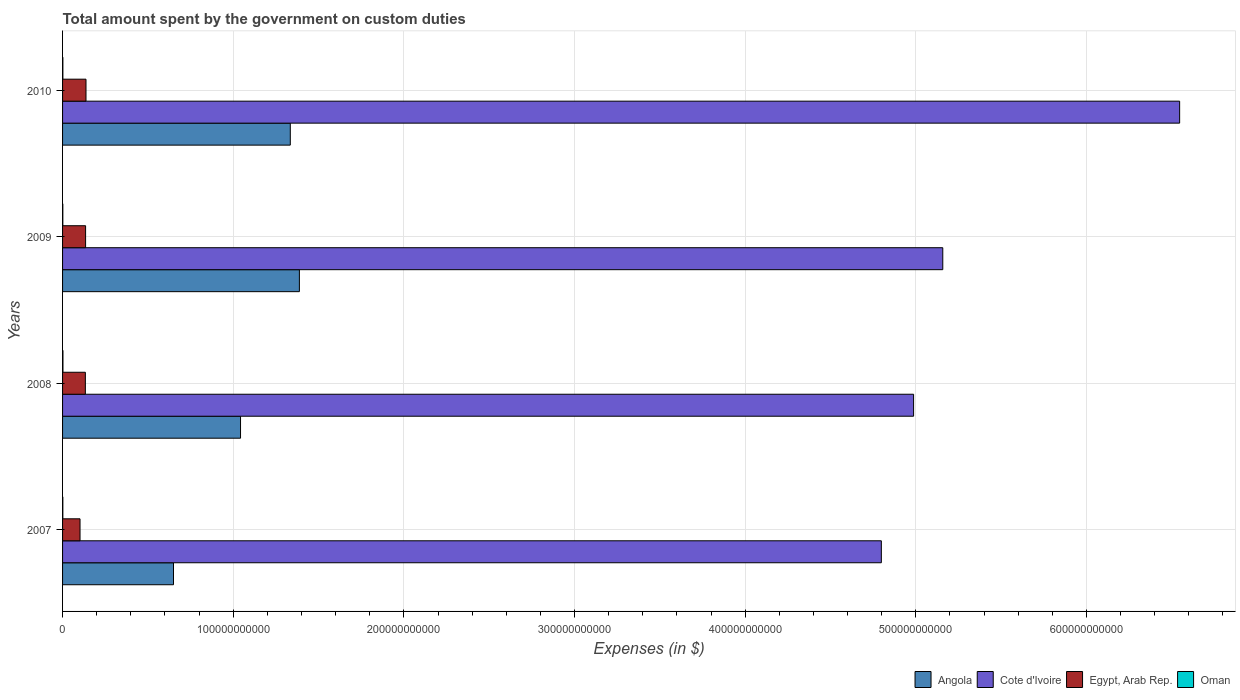Are the number of bars on each tick of the Y-axis equal?
Ensure brevity in your answer.  Yes. What is the label of the 3rd group of bars from the top?
Offer a terse response. 2008. In how many cases, is the number of bars for a given year not equal to the number of legend labels?
Your answer should be very brief. 0. What is the amount spent on custom duties by the government in Oman in 2010?
Offer a terse response. 1.80e+08. Across all years, what is the maximum amount spent on custom duties by the government in Oman?
Your answer should be compact. 2.27e+08. Across all years, what is the minimum amount spent on custom duties by the government in Egypt, Arab Rep.?
Your answer should be very brief. 1.02e+1. In which year was the amount spent on custom duties by the government in Egypt, Arab Rep. minimum?
Your answer should be compact. 2007. What is the total amount spent on custom duties by the government in Oman in the graph?
Your response must be concise. 7.24e+08. What is the difference between the amount spent on custom duties by the government in Egypt, Arab Rep. in 2008 and that in 2009?
Your answer should be very brief. -1.35e+08. What is the difference between the amount spent on custom duties by the government in Angola in 2010 and the amount spent on custom duties by the government in Oman in 2009?
Give a very brief answer. 1.33e+11. What is the average amount spent on custom duties by the government in Angola per year?
Offer a terse response. 1.10e+11. In the year 2007, what is the difference between the amount spent on custom duties by the government in Egypt, Arab Rep. and amount spent on custom duties by the government in Angola?
Offer a very short reply. -5.48e+1. What is the ratio of the amount spent on custom duties by the government in Cote d'Ivoire in 2008 to that in 2009?
Ensure brevity in your answer.  0.97. Is the amount spent on custom duties by the government in Cote d'Ivoire in 2008 less than that in 2009?
Make the answer very short. Yes. What is the difference between the highest and the second highest amount spent on custom duties by the government in Cote d'Ivoire?
Make the answer very short. 1.39e+11. What is the difference between the highest and the lowest amount spent on custom duties by the government in Egypt, Arab Rep.?
Provide a succinct answer. 3.50e+09. Is the sum of the amount spent on custom duties by the government in Egypt, Arab Rep. in 2008 and 2010 greater than the maximum amount spent on custom duties by the government in Oman across all years?
Give a very brief answer. Yes. What does the 1st bar from the top in 2008 represents?
Your response must be concise. Oman. What does the 1st bar from the bottom in 2010 represents?
Give a very brief answer. Angola. How many bars are there?
Keep it short and to the point. 16. Are all the bars in the graph horizontal?
Make the answer very short. Yes. What is the difference between two consecutive major ticks on the X-axis?
Keep it short and to the point. 1.00e+11. Are the values on the major ticks of X-axis written in scientific E-notation?
Ensure brevity in your answer.  No. Does the graph contain any zero values?
Provide a succinct answer. No. Does the graph contain grids?
Ensure brevity in your answer.  Yes. How many legend labels are there?
Your answer should be compact. 4. What is the title of the graph?
Your answer should be very brief. Total amount spent by the government on custom duties. What is the label or title of the X-axis?
Provide a short and direct response. Expenses (in $). What is the label or title of the Y-axis?
Offer a terse response. Years. What is the Expenses (in $) in Angola in 2007?
Provide a succinct answer. 6.50e+1. What is the Expenses (in $) in Cote d'Ivoire in 2007?
Your response must be concise. 4.80e+11. What is the Expenses (in $) of Egypt, Arab Rep. in 2007?
Offer a terse response. 1.02e+1. What is the Expenses (in $) of Oman in 2007?
Give a very brief answer. 1.60e+08. What is the Expenses (in $) in Angola in 2008?
Provide a short and direct response. 1.04e+11. What is the Expenses (in $) in Cote d'Ivoire in 2008?
Your answer should be compact. 4.99e+11. What is the Expenses (in $) of Egypt, Arab Rep. in 2008?
Your answer should be very brief. 1.34e+1. What is the Expenses (in $) of Oman in 2008?
Keep it short and to the point. 2.27e+08. What is the Expenses (in $) of Angola in 2009?
Provide a short and direct response. 1.39e+11. What is the Expenses (in $) of Cote d'Ivoire in 2009?
Provide a short and direct response. 5.16e+11. What is the Expenses (in $) of Egypt, Arab Rep. in 2009?
Your answer should be very brief. 1.35e+1. What is the Expenses (in $) of Oman in 2009?
Give a very brief answer. 1.58e+08. What is the Expenses (in $) in Angola in 2010?
Your response must be concise. 1.33e+11. What is the Expenses (in $) in Cote d'Ivoire in 2010?
Offer a very short reply. 6.55e+11. What is the Expenses (in $) of Egypt, Arab Rep. in 2010?
Your answer should be compact. 1.37e+1. What is the Expenses (in $) in Oman in 2010?
Give a very brief answer. 1.80e+08. Across all years, what is the maximum Expenses (in $) in Angola?
Your response must be concise. 1.39e+11. Across all years, what is the maximum Expenses (in $) of Cote d'Ivoire?
Your answer should be very brief. 6.55e+11. Across all years, what is the maximum Expenses (in $) of Egypt, Arab Rep.?
Make the answer very short. 1.37e+1. Across all years, what is the maximum Expenses (in $) in Oman?
Your response must be concise. 2.27e+08. Across all years, what is the minimum Expenses (in $) of Angola?
Your response must be concise. 6.50e+1. Across all years, what is the minimum Expenses (in $) of Cote d'Ivoire?
Offer a very short reply. 4.80e+11. Across all years, what is the minimum Expenses (in $) of Egypt, Arab Rep.?
Give a very brief answer. 1.02e+1. Across all years, what is the minimum Expenses (in $) of Oman?
Provide a short and direct response. 1.58e+08. What is the total Expenses (in $) in Angola in the graph?
Ensure brevity in your answer.  4.42e+11. What is the total Expenses (in $) in Cote d'Ivoire in the graph?
Keep it short and to the point. 2.15e+12. What is the total Expenses (in $) in Egypt, Arab Rep. in the graph?
Make the answer very short. 5.08e+1. What is the total Expenses (in $) in Oman in the graph?
Provide a succinct answer. 7.24e+08. What is the difference between the Expenses (in $) in Angola in 2007 and that in 2008?
Make the answer very short. -3.93e+1. What is the difference between the Expenses (in $) in Cote d'Ivoire in 2007 and that in 2008?
Your answer should be very brief. -1.89e+1. What is the difference between the Expenses (in $) of Egypt, Arab Rep. in 2007 and that in 2008?
Offer a very short reply. -3.13e+09. What is the difference between the Expenses (in $) of Oman in 2007 and that in 2008?
Your answer should be very brief. -6.70e+07. What is the difference between the Expenses (in $) of Angola in 2007 and that in 2009?
Provide a succinct answer. -7.38e+1. What is the difference between the Expenses (in $) in Cote d'Ivoire in 2007 and that in 2009?
Your answer should be very brief. -3.60e+1. What is the difference between the Expenses (in $) of Egypt, Arab Rep. in 2007 and that in 2009?
Your response must be concise. -3.26e+09. What is the difference between the Expenses (in $) of Oman in 2007 and that in 2009?
Offer a terse response. 1.50e+06. What is the difference between the Expenses (in $) of Angola in 2007 and that in 2010?
Your answer should be very brief. -6.84e+1. What is the difference between the Expenses (in $) of Cote d'Ivoire in 2007 and that in 2010?
Provide a succinct answer. -1.75e+11. What is the difference between the Expenses (in $) in Egypt, Arab Rep. in 2007 and that in 2010?
Ensure brevity in your answer.  -3.50e+09. What is the difference between the Expenses (in $) in Oman in 2007 and that in 2010?
Your response must be concise. -2.00e+07. What is the difference between the Expenses (in $) in Angola in 2008 and that in 2009?
Your answer should be very brief. -3.45e+1. What is the difference between the Expenses (in $) in Cote d'Ivoire in 2008 and that in 2009?
Offer a very short reply. -1.71e+1. What is the difference between the Expenses (in $) of Egypt, Arab Rep. in 2008 and that in 2009?
Offer a very short reply. -1.35e+08. What is the difference between the Expenses (in $) in Oman in 2008 and that in 2009?
Keep it short and to the point. 6.85e+07. What is the difference between the Expenses (in $) in Angola in 2008 and that in 2010?
Keep it short and to the point. -2.92e+1. What is the difference between the Expenses (in $) of Cote d'Ivoire in 2008 and that in 2010?
Provide a short and direct response. -1.56e+11. What is the difference between the Expenses (in $) of Egypt, Arab Rep. in 2008 and that in 2010?
Provide a succinct answer. -3.72e+08. What is the difference between the Expenses (in $) of Oman in 2008 and that in 2010?
Your answer should be very brief. 4.70e+07. What is the difference between the Expenses (in $) in Angola in 2009 and that in 2010?
Provide a succinct answer. 5.33e+09. What is the difference between the Expenses (in $) of Cote d'Ivoire in 2009 and that in 2010?
Give a very brief answer. -1.39e+11. What is the difference between the Expenses (in $) of Egypt, Arab Rep. in 2009 and that in 2010?
Your answer should be compact. -2.37e+08. What is the difference between the Expenses (in $) of Oman in 2009 and that in 2010?
Provide a short and direct response. -2.15e+07. What is the difference between the Expenses (in $) of Angola in 2007 and the Expenses (in $) of Cote d'Ivoire in 2008?
Offer a terse response. -4.34e+11. What is the difference between the Expenses (in $) in Angola in 2007 and the Expenses (in $) in Egypt, Arab Rep. in 2008?
Provide a succinct answer. 5.16e+1. What is the difference between the Expenses (in $) in Angola in 2007 and the Expenses (in $) in Oman in 2008?
Provide a succinct answer. 6.48e+1. What is the difference between the Expenses (in $) in Cote d'Ivoire in 2007 and the Expenses (in $) in Egypt, Arab Rep. in 2008?
Give a very brief answer. 4.66e+11. What is the difference between the Expenses (in $) in Cote d'Ivoire in 2007 and the Expenses (in $) in Oman in 2008?
Offer a terse response. 4.80e+11. What is the difference between the Expenses (in $) in Egypt, Arab Rep. in 2007 and the Expenses (in $) in Oman in 2008?
Ensure brevity in your answer.  1.00e+1. What is the difference between the Expenses (in $) in Angola in 2007 and the Expenses (in $) in Cote d'Ivoire in 2009?
Make the answer very short. -4.51e+11. What is the difference between the Expenses (in $) of Angola in 2007 and the Expenses (in $) of Egypt, Arab Rep. in 2009?
Keep it short and to the point. 5.15e+1. What is the difference between the Expenses (in $) in Angola in 2007 and the Expenses (in $) in Oman in 2009?
Ensure brevity in your answer.  6.48e+1. What is the difference between the Expenses (in $) of Cote d'Ivoire in 2007 and the Expenses (in $) of Egypt, Arab Rep. in 2009?
Give a very brief answer. 4.66e+11. What is the difference between the Expenses (in $) in Cote d'Ivoire in 2007 and the Expenses (in $) in Oman in 2009?
Ensure brevity in your answer.  4.80e+11. What is the difference between the Expenses (in $) of Egypt, Arab Rep. in 2007 and the Expenses (in $) of Oman in 2009?
Offer a terse response. 1.01e+1. What is the difference between the Expenses (in $) in Angola in 2007 and the Expenses (in $) in Cote d'Ivoire in 2010?
Your response must be concise. -5.90e+11. What is the difference between the Expenses (in $) in Angola in 2007 and the Expenses (in $) in Egypt, Arab Rep. in 2010?
Ensure brevity in your answer.  5.13e+1. What is the difference between the Expenses (in $) in Angola in 2007 and the Expenses (in $) in Oman in 2010?
Your response must be concise. 6.48e+1. What is the difference between the Expenses (in $) of Cote d'Ivoire in 2007 and the Expenses (in $) of Egypt, Arab Rep. in 2010?
Your response must be concise. 4.66e+11. What is the difference between the Expenses (in $) of Cote d'Ivoire in 2007 and the Expenses (in $) of Oman in 2010?
Make the answer very short. 4.80e+11. What is the difference between the Expenses (in $) in Egypt, Arab Rep. in 2007 and the Expenses (in $) in Oman in 2010?
Your answer should be very brief. 1.01e+1. What is the difference between the Expenses (in $) in Angola in 2008 and the Expenses (in $) in Cote d'Ivoire in 2009?
Your response must be concise. -4.12e+11. What is the difference between the Expenses (in $) of Angola in 2008 and the Expenses (in $) of Egypt, Arab Rep. in 2009?
Make the answer very short. 9.08e+1. What is the difference between the Expenses (in $) of Angola in 2008 and the Expenses (in $) of Oman in 2009?
Keep it short and to the point. 1.04e+11. What is the difference between the Expenses (in $) of Cote d'Ivoire in 2008 and the Expenses (in $) of Egypt, Arab Rep. in 2009?
Keep it short and to the point. 4.85e+11. What is the difference between the Expenses (in $) in Cote d'Ivoire in 2008 and the Expenses (in $) in Oman in 2009?
Ensure brevity in your answer.  4.99e+11. What is the difference between the Expenses (in $) of Egypt, Arab Rep. in 2008 and the Expenses (in $) of Oman in 2009?
Provide a succinct answer. 1.32e+1. What is the difference between the Expenses (in $) in Angola in 2008 and the Expenses (in $) in Cote d'Ivoire in 2010?
Provide a short and direct response. -5.50e+11. What is the difference between the Expenses (in $) in Angola in 2008 and the Expenses (in $) in Egypt, Arab Rep. in 2010?
Make the answer very short. 9.06e+1. What is the difference between the Expenses (in $) in Angola in 2008 and the Expenses (in $) in Oman in 2010?
Your response must be concise. 1.04e+11. What is the difference between the Expenses (in $) of Cote d'Ivoire in 2008 and the Expenses (in $) of Egypt, Arab Rep. in 2010?
Provide a succinct answer. 4.85e+11. What is the difference between the Expenses (in $) of Cote d'Ivoire in 2008 and the Expenses (in $) of Oman in 2010?
Offer a very short reply. 4.99e+11. What is the difference between the Expenses (in $) in Egypt, Arab Rep. in 2008 and the Expenses (in $) in Oman in 2010?
Offer a terse response. 1.32e+1. What is the difference between the Expenses (in $) of Angola in 2009 and the Expenses (in $) of Cote d'Ivoire in 2010?
Your answer should be compact. -5.16e+11. What is the difference between the Expenses (in $) of Angola in 2009 and the Expenses (in $) of Egypt, Arab Rep. in 2010?
Keep it short and to the point. 1.25e+11. What is the difference between the Expenses (in $) of Angola in 2009 and the Expenses (in $) of Oman in 2010?
Your answer should be compact. 1.39e+11. What is the difference between the Expenses (in $) of Cote d'Ivoire in 2009 and the Expenses (in $) of Egypt, Arab Rep. in 2010?
Make the answer very short. 5.02e+11. What is the difference between the Expenses (in $) of Cote d'Ivoire in 2009 and the Expenses (in $) of Oman in 2010?
Provide a succinct answer. 5.16e+11. What is the difference between the Expenses (in $) of Egypt, Arab Rep. in 2009 and the Expenses (in $) of Oman in 2010?
Keep it short and to the point. 1.33e+1. What is the average Expenses (in $) of Angola per year?
Provide a short and direct response. 1.10e+11. What is the average Expenses (in $) in Cote d'Ivoire per year?
Make the answer very short. 5.37e+11. What is the average Expenses (in $) in Egypt, Arab Rep. per year?
Your response must be concise. 1.27e+1. What is the average Expenses (in $) in Oman per year?
Your response must be concise. 1.81e+08. In the year 2007, what is the difference between the Expenses (in $) in Angola and Expenses (in $) in Cote d'Ivoire?
Your answer should be very brief. -4.15e+11. In the year 2007, what is the difference between the Expenses (in $) in Angola and Expenses (in $) in Egypt, Arab Rep.?
Your answer should be compact. 5.48e+1. In the year 2007, what is the difference between the Expenses (in $) of Angola and Expenses (in $) of Oman?
Make the answer very short. 6.48e+1. In the year 2007, what is the difference between the Expenses (in $) in Cote d'Ivoire and Expenses (in $) in Egypt, Arab Rep.?
Provide a succinct answer. 4.70e+11. In the year 2007, what is the difference between the Expenses (in $) of Cote d'Ivoire and Expenses (in $) of Oman?
Give a very brief answer. 4.80e+11. In the year 2007, what is the difference between the Expenses (in $) in Egypt, Arab Rep. and Expenses (in $) in Oman?
Give a very brief answer. 1.01e+1. In the year 2008, what is the difference between the Expenses (in $) in Angola and Expenses (in $) in Cote d'Ivoire?
Ensure brevity in your answer.  -3.94e+11. In the year 2008, what is the difference between the Expenses (in $) of Angola and Expenses (in $) of Egypt, Arab Rep.?
Keep it short and to the point. 9.09e+1. In the year 2008, what is the difference between the Expenses (in $) of Angola and Expenses (in $) of Oman?
Provide a succinct answer. 1.04e+11. In the year 2008, what is the difference between the Expenses (in $) of Cote d'Ivoire and Expenses (in $) of Egypt, Arab Rep.?
Provide a short and direct response. 4.85e+11. In the year 2008, what is the difference between the Expenses (in $) of Cote d'Ivoire and Expenses (in $) of Oman?
Your answer should be compact. 4.98e+11. In the year 2008, what is the difference between the Expenses (in $) in Egypt, Arab Rep. and Expenses (in $) in Oman?
Ensure brevity in your answer.  1.31e+1. In the year 2009, what is the difference between the Expenses (in $) of Angola and Expenses (in $) of Cote d'Ivoire?
Your answer should be compact. -3.77e+11. In the year 2009, what is the difference between the Expenses (in $) in Angola and Expenses (in $) in Egypt, Arab Rep.?
Make the answer very short. 1.25e+11. In the year 2009, what is the difference between the Expenses (in $) in Angola and Expenses (in $) in Oman?
Provide a succinct answer. 1.39e+11. In the year 2009, what is the difference between the Expenses (in $) in Cote d'Ivoire and Expenses (in $) in Egypt, Arab Rep.?
Provide a short and direct response. 5.02e+11. In the year 2009, what is the difference between the Expenses (in $) of Cote d'Ivoire and Expenses (in $) of Oman?
Provide a short and direct response. 5.16e+11. In the year 2009, what is the difference between the Expenses (in $) of Egypt, Arab Rep. and Expenses (in $) of Oman?
Your answer should be compact. 1.33e+1. In the year 2010, what is the difference between the Expenses (in $) in Angola and Expenses (in $) in Cote d'Ivoire?
Provide a succinct answer. -5.21e+11. In the year 2010, what is the difference between the Expenses (in $) of Angola and Expenses (in $) of Egypt, Arab Rep.?
Provide a short and direct response. 1.20e+11. In the year 2010, what is the difference between the Expenses (in $) of Angola and Expenses (in $) of Oman?
Your answer should be compact. 1.33e+11. In the year 2010, what is the difference between the Expenses (in $) of Cote d'Ivoire and Expenses (in $) of Egypt, Arab Rep.?
Keep it short and to the point. 6.41e+11. In the year 2010, what is the difference between the Expenses (in $) in Cote d'Ivoire and Expenses (in $) in Oman?
Your answer should be compact. 6.54e+11. In the year 2010, what is the difference between the Expenses (in $) in Egypt, Arab Rep. and Expenses (in $) in Oman?
Make the answer very short. 1.36e+1. What is the ratio of the Expenses (in $) of Angola in 2007 to that in 2008?
Offer a very short reply. 0.62. What is the ratio of the Expenses (in $) of Cote d'Ivoire in 2007 to that in 2008?
Ensure brevity in your answer.  0.96. What is the ratio of the Expenses (in $) in Egypt, Arab Rep. in 2007 to that in 2008?
Provide a short and direct response. 0.77. What is the ratio of the Expenses (in $) in Oman in 2007 to that in 2008?
Your answer should be very brief. 0.7. What is the ratio of the Expenses (in $) in Angola in 2007 to that in 2009?
Offer a terse response. 0.47. What is the ratio of the Expenses (in $) in Cote d'Ivoire in 2007 to that in 2009?
Ensure brevity in your answer.  0.93. What is the ratio of the Expenses (in $) in Egypt, Arab Rep. in 2007 to that in 2009?
Your answer should be compact. 0.76. What is the ratio of the Expenses (in $) in Oman in 2007 to that in 2009?
Your answer should be compact. 1.01. What is the ratio of the Expenses (in $) of Angola in 2007 to that in 2010?
Your response must be concise. 0.49. What is the ratio of the Expenses (in $) in Cote d'Ivoire in 2007 to that in 2010?
Make the answer very short. 0.73. What is the ratio of the Expenses (in $) of Egypt, Arab Rep. in 2007 to that in 2010?
Provide a succinct answer. 0.75. What is the ratio of the Expenses (in $) of Oman in 2007 to that in 2010?
Provide a succinct answer. 0.89. What is the ratio of the Expenses (in $) of Angola in 2008 to that in 2009?
Offer a very short reply. 0.75. What is the ratio of the Expenses (in $) of Cote d'Ivoire in 2008 to that in 2009?
Your answer should be very brief. 0.97. What is the ratio of the Expenses (in $) of Oman in 2008 to that in 2009?
Provide a succinct answer. 1.43. What is the ratio of the Expenses (in $) in Angola in 2008 to that in 2010?
Give a very brief answer. 0.78. What is the ratio of the Expenses (in $) in Cote d'Ivoire in 2008 to that in 2010?
Keep it short and to the point. 0.76. What is the ratio of the Expenses (in $) of Egypt, Arab Rep. in 2008 to that in 2010?
Ensure brevity in your answer.  0.97. What is the ratio of the Expenses (in $) in Oman in 2008 to that in 2010?
Your answer should be very brief. 1.26. What is the ratio of the Expenses (in $) of Angola in 2009 to that in 2010?
Provide a succinct answer. 1.04. What is the ratio of the Expenses (in $) of Cote d'Ivoire in 2009 to that in 2010?
Your answer should be very brief. 0.79. What is the ratio of the Expenses (in $) of Egypt, Arab Rep. in 2009 to that in 2010?
Provide a succinct answer. 0.98. What is the ratio of the Expenses (in $) of Oman in 2009 to that in 2010?
Keep it short and to the point. 0.88. What is the difference between the highest and the second highest Expenses (in $) of Angola?
Ensure brevity in your answer.  5.33e+09. What is the difference between the highest and the second highest Expenses (in $) of Cote d'Ivoire?
Your response must be concise. 1.39e+11. What is the difference between the highest and the second highest Expenses (in $) of Egypt, Arab Rep.?
Offer a very short reply. 2.37e+08. What is the difference between the highest and the second highest Expenses (in $) of Oman?
Your answer should be very brief. 4.70e+07. What is the difference between the highest and the lowest Expenses (in $) of Angola?
Your answer should be very brief. 7.38e+1. What is the difference between the highest and the lowest Expenses (in $) in Cote d'Ivoire?
Offer a very short reply. 1.75e+11. What is the difference between the highest and the lowest Expenses (in $) of Egypt, Arab Rep.?
Offer a terse response. 3.50e+09. What is the difference between the highest and the lowest Expenses (in $) of Oman?
Make the answer very short. 6.85e+07. 